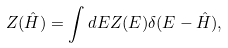<formula> <loc_0><loc_0><loc_500><loc_500>Z ( \hat { H } ) = \int d E Z ( E ) \delta ( E - \hat { H } ) ,</formula> 